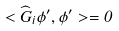Convert formula to latex. <formula><loc_0><loc_0><loc_500><loc_500>< \widehat { G } _ { i } \phi ^ { \prime } , \phi ^ { \prime } > = 0</formula> 